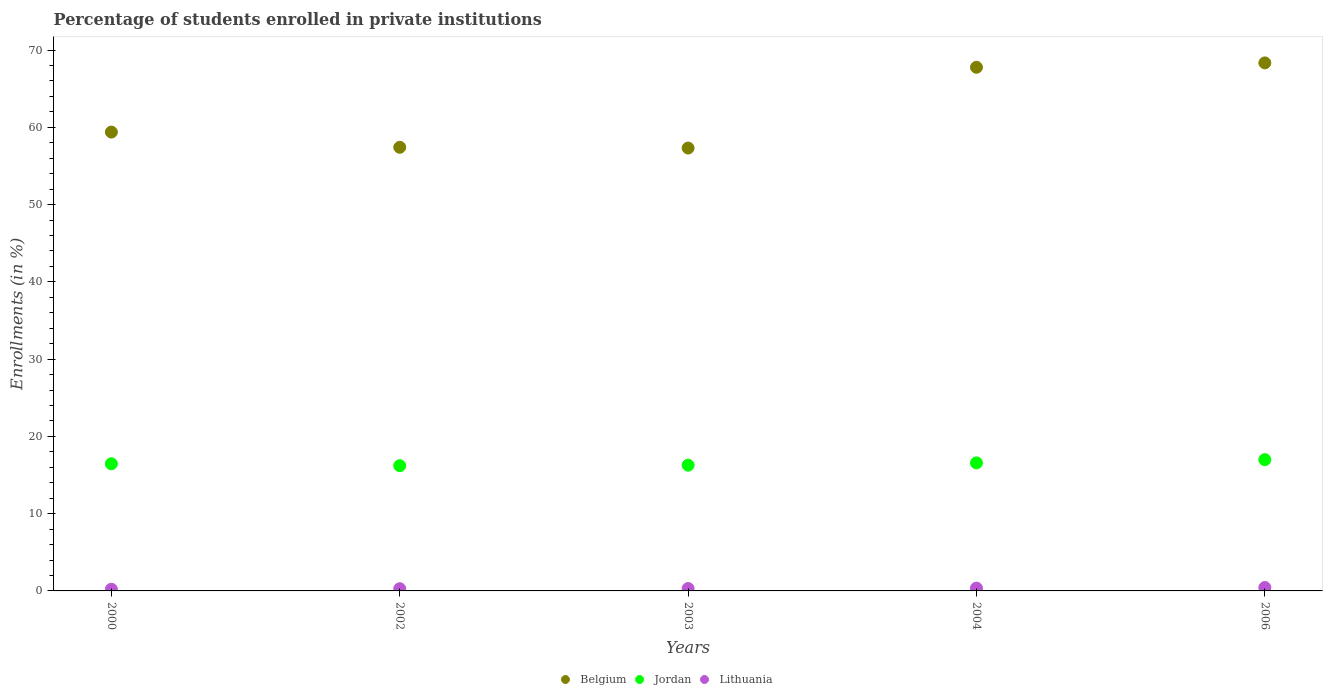Is the number of dotlines equal to the number of legend labels?
Your answer should be very brief. Yes. What is the percentage of trained teachers in Jordan in 2006?
Provide a short and direct response. 16.99. Across all years, what is the maximum percentage of trained teachers in Jordan?
Offer a terse response. 16.99. Across all years, what is the minimum percentage of trained teachers in Jordan?
Offer a terse response. 16.21. What is the total percentage of trained teachers in Jordan in the graph?
Your answer should be very brief. 82.49. What is the difference between the percentage of trained teachers in Belgium in 2003 and that in 2004?
Keep it short and to the point. -10.45. What is the difference between the percentage of trained teachers in Lithuania in 2002 and the percentage of trained teachers in Jordan in 2003?
Give a very brief answer. -15.99. What is the average percentage of trained teachers in Belgium per year?
Provide a short and direct response. 62.04. In the year 2003, what is the difference between the percentage of trained teachers in Lithuania and percentage of trained teachers in Belgium?
Keep it short and to the point. -57.01. In how many years, is the percentage of trained teachers in Jordan greater than 14 %?
Your answer should be compact. 5. What is the ratio of the percentage of trained teachers in Belgium in 2000 to that in 2006?
Give a very brief answer. 0.87. Is the percentage of trained teachers in Lithuania in 2002 less than that in 2004?
Offer a very short reply. Yes. What is the difference between the highest and the second highest percentage of trained teachers in Belgium?
Your response must be concise. 0.57. What is the difference between the highest and the lowest percentage of trained teachers in Belgium?
Give a very brief answer. 11.02. Is it the case that in every year, the sum of the percentage of trained teachers in Jordan and percentage of trained teachers in Belgium  is greater than the percentage of trained teachers in Lithuania?
Make the answer very short. Yes. Does the percentage of trained teachers in Jordan monotonically increase over the years?
Your response must be concise. No. Is the percentage of trained teachers in Lithuania strictly greater than the percentage of trained teachers in Belgium over the years?
Ensure brevity in your answer.  No. How many dotlines are there?
Offer a terse response. 3. What is the difference between two consecutive major ticks on the Y-axis?
Offer a very short reply. 10. Does the graph contain any zero values?
Your answer should be very brief. No. Does the graph contain grids?
Provide a succinct answer. No. Where does the legend appear in the graph?
Offer a very short reply. Bottom center. How many legend labels are there?
Provide a short and direct response. 3. What is the title of the graph?
Your answer should be very brief. Percentage of students enrolled in private institutions. What is the label or title of the Y-axis?
Ensure brevity in your answer.  Enrollments (in %). What is the Enrollments (in %) in Belgium in 2000?
Keep it short and to the point. 59.38. What is the Enrollments (in %) of Jordan in 2000?
Provide a short and direct response. 16.46. What is the Enrollments (in %) of Lithuania in 2000?
Provide a short and direct response. 0.22. What is the Enrollments (in %) of Belgium in 2002?
Ensure brevity in your answer.  57.41. What is the Enrollments (in %) of Jordan in 2002?
Give a very brief answer. 16.21. What is the Enrollments (in %) in Lithuania in 2002?
Ensure brevity in your answer.  0.28. What is the Enrollments (in %) of Belgium in 2003?
Your answer should be compact. 57.31. What is the Enrollments (in %) in Jordan in 2003?
Give a very brief answer. 16.27. What is the Enrollments (in %) of Lithuania in 2003?
Make the answer very short. 0.31. What is the Enrollments (in %) in Belgium in 2004?
Give a very brief answer. 67.77. What is the Enrollments (in %) of Jordan in 2004?
Provide a succinct answer. 16.57. What is the Enrollments (in %) in Lithuania in 2004?
Ensure brevity in your answer.  0.36. What is the Enrollments (in %) of Belgium in 2006?
Offer a very short reply. 68.33. What is the Enrollments (in %) in Jordan in 2006?
Your answer should be very brief. 16.99. What is the Enrollments (in %) in Lithuania in 2006?
Your response must be concise. 0.44. Across all years, what is the maximum Enrollments (in %) of Belgium?
Ensure brevity in your answer.  68.33. Across all years, what is the maximum Enrollments (in %) of Jordan?
Offer a very short reply. 16.99. Across all years, what is the maximum Enrollments (in %) of Lithuania?
Provide a succinct answer. 0.44. Across all years, what is the minimum Enrollments (in %) in Belgium?
Your answer should be compact. 57.31. Across all years, what is the minimum Enrollments (in %) of Jordan?
Provide a succinct answer. 16.21. Across all years, what is the minimum Enrollments (in %) of Lithuania?
Ensure brevity in your answer.  0.22. What is the total Enrollments (in %) of Belgium in the graph?
Offer a terse response. 310.21. What is the total Enrollments (in %) of Jordan in the graph?
Provide a succinct answer. 82.49. What is the total Enrollments (in %) of Lithuania in the graph?
Your response must be concise. 1.61. What is the difference between the Enrollments (in %) in Belgium in 2000 and that in 2002?
Offer a very short reply. 1.97. What is the difference between the Enrollments (in %) in Jordan in 2000 and that in 2002?
Your answer should be compact. 0.25. What is the difference between the Enrollments (in %) of Lithuania in 2000 and that in 2002?
Offer a terse response. -0.07. What is the difference between the Enrollments (in %) of Belgium in 2000 and that in 2003?
Provide a short and direct response. 2.07. What is the difference between the Enrollments (in %) in Jordan in 2000 and that in 2003?
Your response must be concise. 0.18. What is the difference between the Enrollments (in %) in Lithuania in 2000 and that in 2003?
Ensure brevity in your answer.  -0.09. What is the difference between the Enrollments (in %) of Belgium in 2000 and that in 2004?
Your answer should be very brief. -8.39. What is the difference between the Enrollments (in %) in Jordan in 2000 and that in 2004?
Your answer should be very brief. -0.11. What is the difference between the Enrollments (in %) in Lithuania in 2000 and that in 2004?
Your response must be concise. -0.14. What is the difference between the Enrollments (in %) of Belgium in 2000 and that in 2006?
Offer a very short reply. -8.95. What is the difference between the Enrollments (in %) in Jordan in 2000 and that in 2006?
Provide a short and direct response. -0.53. What is the difference between the Enrollments (in %) in Lithuania in 2000 and that in 2006?
Provide a succinct answer. -0.22. What is the difference between the Enrollments (in %) of Belgium in 2002 and that in 2003?
Your answer should be very brief. 0.1. What is the difference between the Enrollments (in %) of Jordan in 2002 and that in 2003?
Offer a terse response. -0.06. What is the difference between the Enrollments (in %) in Lithuania in 2002 and that in 2003?
Offer a terse response. -0.02. What is the difference between the Enrollments (in %) in Belgium in 2002 and that in 2004?
Provide a short and direct response. -10.36. What is the difference between the Enrollments (in %) of Jordan in 2002 and that in 2004?
Your response must be concise. -0.36. What is the difference between the Enrollments (in %) of Lithuania in 2002 and that in 2004?
Provide a short and direct response. -0.08. What is the difference between the Enrollments (in %) in Belgium in 2002 and that in 2006?
Offer a very short reply. -10.92. What is the difference between the Enrollments (in %) of Jordan in 2002 and that in 2006?
Provide a short and direct response. -0.78. What is the difference between the Enrollments (in %) of Lithuania in 2002 and that in 2006?
Provide a short and direct response. -0.16. What is the difference between the Enrollments (in %) of Belgium in 2003 and that in 2004?
Offer a very short reply. -10.45. What is the difference between the Enrollments (in %) in Jordan in 2003 and that in 2004?
Ensure brevity in your answer.  -0.3. What is the difference between the Enrollments (in %) of Lithuania in 2003 and that in 2004?
Offer a very short reply. -0.06. What is the difference between the Enrollments (in %) of Belgium in 2003 and that in 2006?
Make the answer very short. -11.02. What is the difference between the Enrollments (in %) in Jordan in 2003 and that in 2006?
Your answer should be compact. -0.71. What is the difference between the Enrollments (in %) in Lithuania in 2003 and that in 2006?
Provide a succinct answer. -0.14. What is the difference between the Enrollments (in %) in Belgium in 2004 and that in 2006?
Provide a succinct answer. -0.57. What is the difference between the Enrollments (in %) of Jordan in 2004 and that in 2006?
Ensure brevity in your answer.  -0.42. What is the difference between the Enrollments (in %) in Lithuania in 2004 and that in 2006?
Keep it short and to the point. -0.08. What is the difference between the Enrollments (in %) in Belgium in 2000 and the Enrollments (in %) in Jordan in 2002?
Make the answer very short. 43.17. What is the difference between the Enrollments (in %) of Belgium in 2000 and the Enrollments (in %) of Lithuania in 2002?
Ensure brevity in your answer.  59.1. What is the difference between the Enrollments (in %) of Jordan in 2000 and the Enrollments (in %) of Lithuania in 2002?
Provide a short and direct response. 16.17. What is the difference between the Enrollments (in %) in Belgium in 2000 and the Enrollments (in %) in Jordan in 2003?
Give a very brief answer. 43.11. What is the difference between the Enrollments (in %) in Belgium in 2000 and the Enrollments (in %) in Lithuania in 2003?
Your answer should be compact. 59.07. What is the difference between the Enrollments (in %) of Jordan in 2000 and the Enrollments (in %) of Lithuania in 2003?
Your response must be concise. 16.15. What is the difference between the Enrollments (in %) of Belgium in 2000 and the Enrollments (in %) of Jordan in 2004?
Your answer should be very brief. 42.81. What is the difference between the Enrollments (in %) of Belgium in 2000 and the Enrollments (in %) of Lithuania in 2004?
Your response must be concise. 59.02. What is the difference between the Enrollments (in %) of Jordan in 2000 and the Enrollments (in %) of Lithuania in 2004?
Make the answer very short. 16.1. What is the difference between the Enrollments (in %) in Belgium in 2000 and the Enrollments (in %) in Jordan in 2006?
Give a very brief answer. 42.39. What is the difference between the Enrollments (in %) of Belgium in 2000 and the Enrollments (in %) of Lithuania in 2006?
Give a very brief answer. 58.94. What is the difference between the Enrollments (in %) in Jordan in 2000 and the Enrollments (in %) in Lithuania in 2006?
Ensure brevity in your answer.  16.02. What is the difference between the Enrollments (in %) of Belgium in 2002 and the Enrollments (in %) of Jordan in 2003?
Provide a short and direct response. 41.14. What is the difference between the Enrollments (in %) of Belgium in 2002 and the Enrollments (in %) of Lithuania in 2003?
Offer a very short reply. 57.11. What is the difference between the Enrollments (in %) in Jordan in 2002 and the Enrollments (in %) in Lithuania in 2003?
Offer a very short reply. 15.9. What is the difference between the Enrollments (in %) in Belgium in 2002 and the Enrollments (in %) in Jordan in 2004?
Keep it short and to the point. 40.84. What is the difference between the Enrollments (in %) in Belgium in 2002 and the Enrollments (in %) in Lithuania in 2004?
Provide a succinct answer. 57.05. What is the difference between the Enrollments (in %) of Jordan in 2002 and the Enrollments (in %) of Lithuania in 2004?
Make the answer very short. 15.85. What is the difference between the Enrollments (in %) in Belgium in 2002 and the Enrollments (in %) in Jordan in 2006?
Ensure brevity in your answer.  40.42. What is the difference between the Enrollments (in %) in Belgium in 2002 and the Enrollments (in %) in Lithuania in 2006?
Make the answer very short. 56.97. What is the difference between the Enrollments (in %) of Jordan in 2002 and the Enrollments (in %) of Lithuania in 2006?
Ensure brevity in your answer.  15.77. What is the difference between the Enrollments (in %) in Belgium in 2003 and the Enrollments (in %) in Jordan in 2004?
Your answer should be compact. 40.74. What is the difference between the Enrollments (in %) of Belgium in 2003 and the Enrollments (in %) of Lithuania in 2004?
Your answer should be very brief. 56.95. What is the difference between the Enrollments (in %) in Jordan in 2003 and the Enrollments (in %) in Lithuania in 2004?
Provide a short and direct response. 15.91. What is the difference between the Enrollments (in %) of Belgium in 2003 and the Enrollments (in %) of Jordan in 2006?
Your response must be concise. 40.33. What is the difference between the Enrollments (in %) of Belgium in 2003 and the Enrollments (in %) of Lithuania in 2006?
Keep it short and to the point. 56.87. What is the difference between the Enrollments (in %) in Jordan in 2003 and the Enrollments (in %) in Lithuania in 2006?
Offer a terse response. 15.83. What is the difference between the Enrollments (in %) in Belgium in 2004 and the Enrollments (in %) in Jordan in 2006?
Your answer should be very brief. 50.78. What is the difference between the Enrollments (in %) in Belgium in 2004 and the Enrollments (in %) in Lithuania in 2006?
Make the answer very short. 67.33. What is the difference between the Enrollments (in %) of Jordan in 2004 and the Enrollments (in %) of Lithuania in 2006?
Ensure brevity in your answer.  16.13. What is the average Enrollments (in %) of Belgium per year?
Offer a very short reply. 62.04. What is the average Enrollments (in %) in Jordan per year?
Ensure brevity in your answer.  16.5. What is the average Enrollments (in %) in Lithuania per year?
Give a very brief answer. 0.32. In the year 2000, what is the difference between the Enrollments (in %) of Belgium and Enrollments (in %) of Jordan?
Your answer should be compact. 42.92. In the year 2000, what is the difference between the Enrollments (in %) of Belgium and Enrollments (in %) of Lithuania?
Give a very brief answer. 59.16. In the year 2000, what is the difference between the Enrollments (in %) of Jordan and Enrollments (in %) of Lithuania?
Offer a very short reply. 16.24. In the year 2002, what is the difference between the Enrollments (in %) in Belgium and Enrollments (in %) in Jordan?
Offer a terse response. 41.2. In the year 2002, what is the difference between the Enrollments (in %) in Belgium and Enrollments (in %) in Lithuania?
Your answer should be compact. 57.13. In the year 2002, what is the difference between the Enrollments (in %) in Jordan and Enrollments (in %) in Lithuania?
Offer a very short reply. 15.92. In the year 2003, what is the difference between the Enrollments (in %) of Belgium and Enrollments (in %) of Jordan?
Offer a terse response. 41.04. In the year 2003, what is the difference between the Enrollments (in %) of Belgium and Enrollments (in %) of Lithuania?
Keep it short and to the point. 57.01. In the year 2003, what is the difference between the Enrollments (in %) of Jordan and Enrollments (in %) of Lithuania?
Provide a succinct answer. 15.97. In the year 2004, what is the difference between the Enrollments (in %) in Belgium and Enrollments (in %) in Jordan?
Provide a succinct answer. 51.2. In the year 2004, what is the difference between the Enrollments (in %) of Belgium and Enrollments (in %) of Lithuania?
Offer a terse response. 67.41. In the year 2004, what is the difference between the Enrollments (in %) in Jordan and Enrollments (in %) in Lithuania?
Your response must be concise. 16.21. In the year 2006, what is the difference between the Enrollments (in %) of Belgium and Enrollments (in %) of Jordan?
Offer a very short reply. 51.35. In the year 2006, what is the difference between the Enrollments (in %) in Belgium and Enrollments (in %) in Lithuania?
Offer a terse response. 67.89. In the year 2006, what is the difference between the Enrollments (in %) in Jordan and Enrollments (in %) in Lithuania?
Keep it short and to the point. 16.55. What is the ratio of the Enrollments (in %) in Belgium in 2000 to that in 2002?
Your answer should be compact. 1.03. What is the ratio of the Enrollments (in %) in Jordan in 2000 to that in 2002?
Provide a succinct answer. 1.02. What is the ratio of the Enrollments (in %) of Lithuania in 2000 to that in 2002?
Offer a terse response. 0.76. What is the ratio of the Enrollments (in %) of Belgium in 2000 to that in 2003?
Offer a terse response. 1.04. What is the ratio of the Enrollments (in %) of Jordan in 2000 to that in 2003?
Offer a very short reply. 1.01. What is the ratio of the Enrollments (in %) in Lithuania in 2000 to that in 2003?
Your answer should be compact. 0.71. What is the ratio of the Enrollments (in %) of Belgium in 2000 to that in 2004?
Make the answer very short. 0.88. What is the ratio of the Enrollments (in %) of Lithuania in 2000 to that in 2004?
Give a very brief answer. 0.6. What is the ratio of the Enrollments (in %) in Belgium in 2000 to that in 2006?
Give a very brief answer. 0.87. What is the ratio of the Enrollments (in %) in Jordan in 2000 to that in 2006?
Provide a short and direct response. 0.97. What is the ratio of the Enrollments (in %) in Lithuania in 2000 to that in 2006?
Provide a succinct answer. 0.49. What is the ratio of the Enrollments (in %) of Belgium in 2002 to that in 2003?
Offer a terse response. 1. What is the ratio of the Enrollments (in %) in Lithuania in 2002 to that in 2003?
Ensure brevity in your answer.  0.93. What is the ratio of the Enrollments (in %) of Belgium in 2002 to that in 2004?
Your response must be concise. 0.85. What is the ratio of the Enrollments (in %) of Jordan in 2002 to that in 2004?
Provide a short and direct response. 0.98. What is the ratio of the Enrollments (in %) of Lithuania in 2002 to that in 2004?
Provide a succinct answer. 0.79. What is the ratio of the Enrollments (in %) of Belgium in 2002 to that in 2006?
Provide a succinct answer. 0.84. What is the ratio of the Enrollments (in %) in Jordan in 2002 to that in 2006?
Your answer should be very brief. 0.95. What is the ratio of the Enrollments (in %) in Lithuania in 2002 to that in 2006?
Your answer should be compact. 0.64. What is the ratio of the Enrollments (in %) in Belgium in 2003 to that in 2004?
Provide a short and direct response. 0.85. What is the ratio of the Enrollments (in %) in Jordan in 2003 to that in 2004?
Your answer should be compact. 0.98. What is the ratio of the Enrollments (in %) in Lithuania in 2003 to that in 2004?
Offer a very short reply. 0.85. What is the ratio of the Enrollments (in %) in Belgium in 2003 to that in 2006?
Provide a succinct answer. 0.84. What is the ratio of the Enrollments (in %) in Jordan in 2003 to that in 2006?
Your answer should be very brief. 0.96. What is the ratio of the Enrollments (in %) in Lithuania in 2003 to that in 2006?
Provide a short and direct response. 0.69. What is the ratio of the Enrollments (in %) of Belgium in 2004 to that in 2006?
Offer a terse response. 0.99. What is the ratio of the Enrollments (in %) of Jordan in 2004 to that in 2006?
Make the answer very short. 0.98. What is the ratio of the Enrollments (in %) in Lithuania in 2004 to that in 2006?
Provide a short and direct response. 0.82. What is the difference between the highest and the second highest Enrollments (in %) in Belgium?
Your answer should be very brief. 0.57. What is the difference between the highest and the second highest Enrollments (in %) of Jordan?
Make the answer very short. 0.42. What is the difference between the highest and the second highest Enrollments (in %) in Lithuania?
Your answer should be very brief. 0.08. What is the difference between the highest and the lowest Enrollments (in %) in Belgium?
Ensure brevity in your answer.  11.02. What is the difference between the highest and the lowest Enrollments (in %) of Lithuania?
Give a very brief answer. 0.22. 